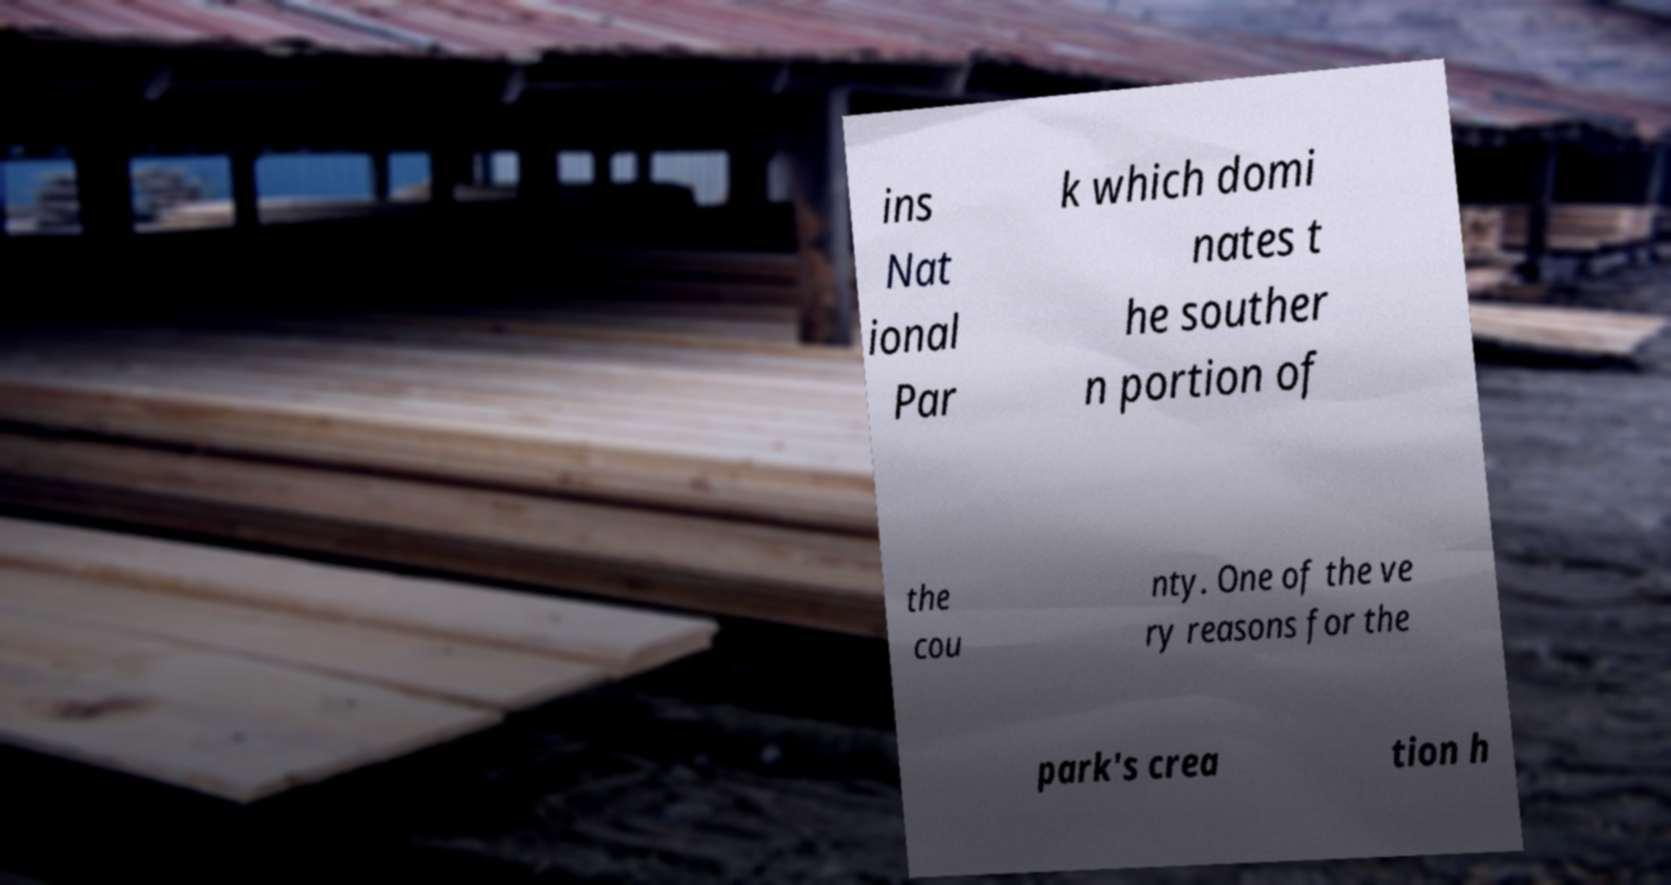What messages or text are displayed in this image? I need them in a readable, typed format. ins Nat ional Par k which domi nates t he souther n portion of the cou nty. One of the ve ry reasons for the park's crea tion h 